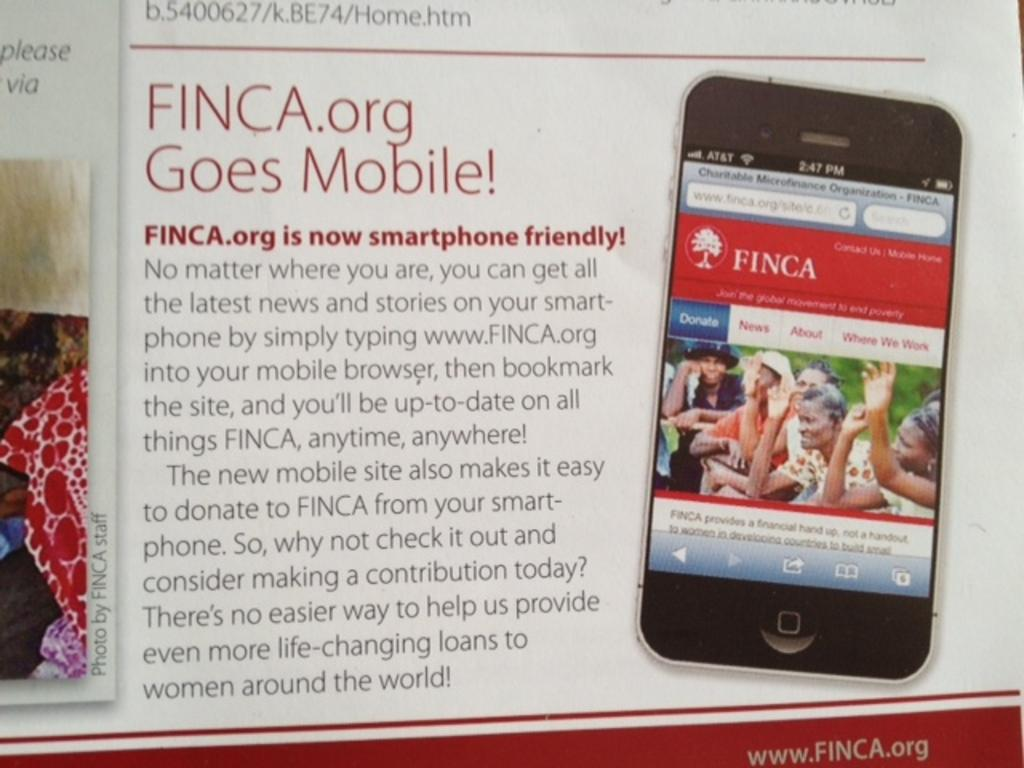<image>
Summarize the visual content of the image. an advertisement for finca or going mobile with an illustration of a phone on its side. 